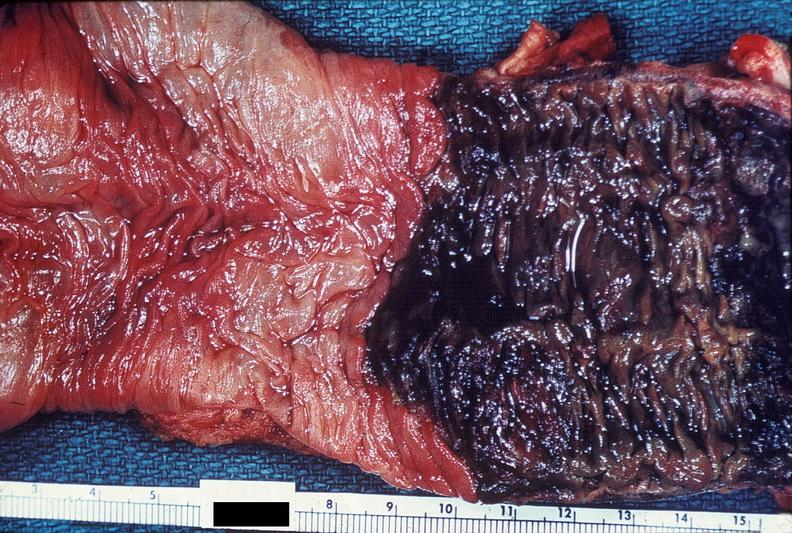s gastrointestinal present?
Answer the question using a single word or phrase. Yes 